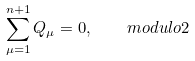Convert formula to latex. <formula><loc_0><loc_0><loc_500><loc_500>\sum _ { \mu = 1 } ^ { n + 1 } Q _ { \mu } = 0 , \quad m o d u l o 2</formula> 